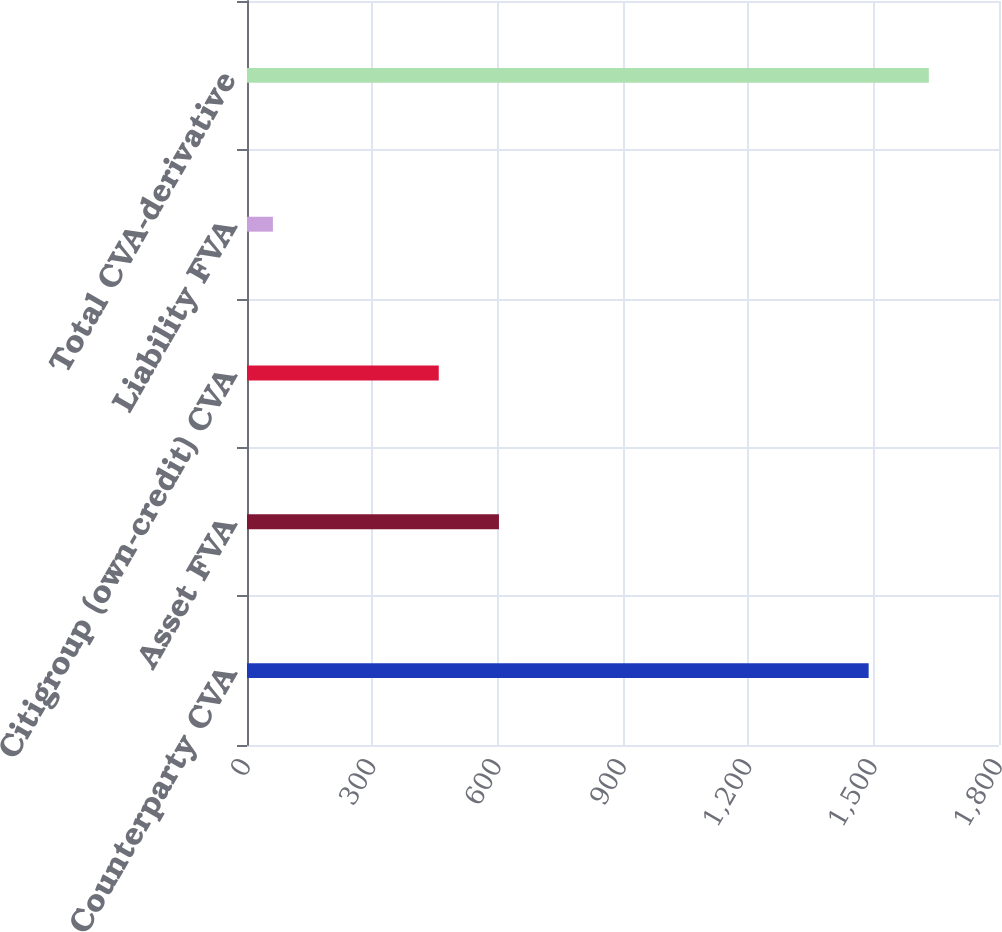<chart> <loc_0><loc_0><loc_500><loc_500><bar_chart><fcel>Counterparty CVA<fcel>Asset FVA<fcel>Citigroup (own-credit) CVA<fcel>Liability FVA<fcel>Total CVA-derivative<nl><fcel>1488<fcel>603.1<fcel>459<fcel>62<fcel>1632.1<nl></chart> 